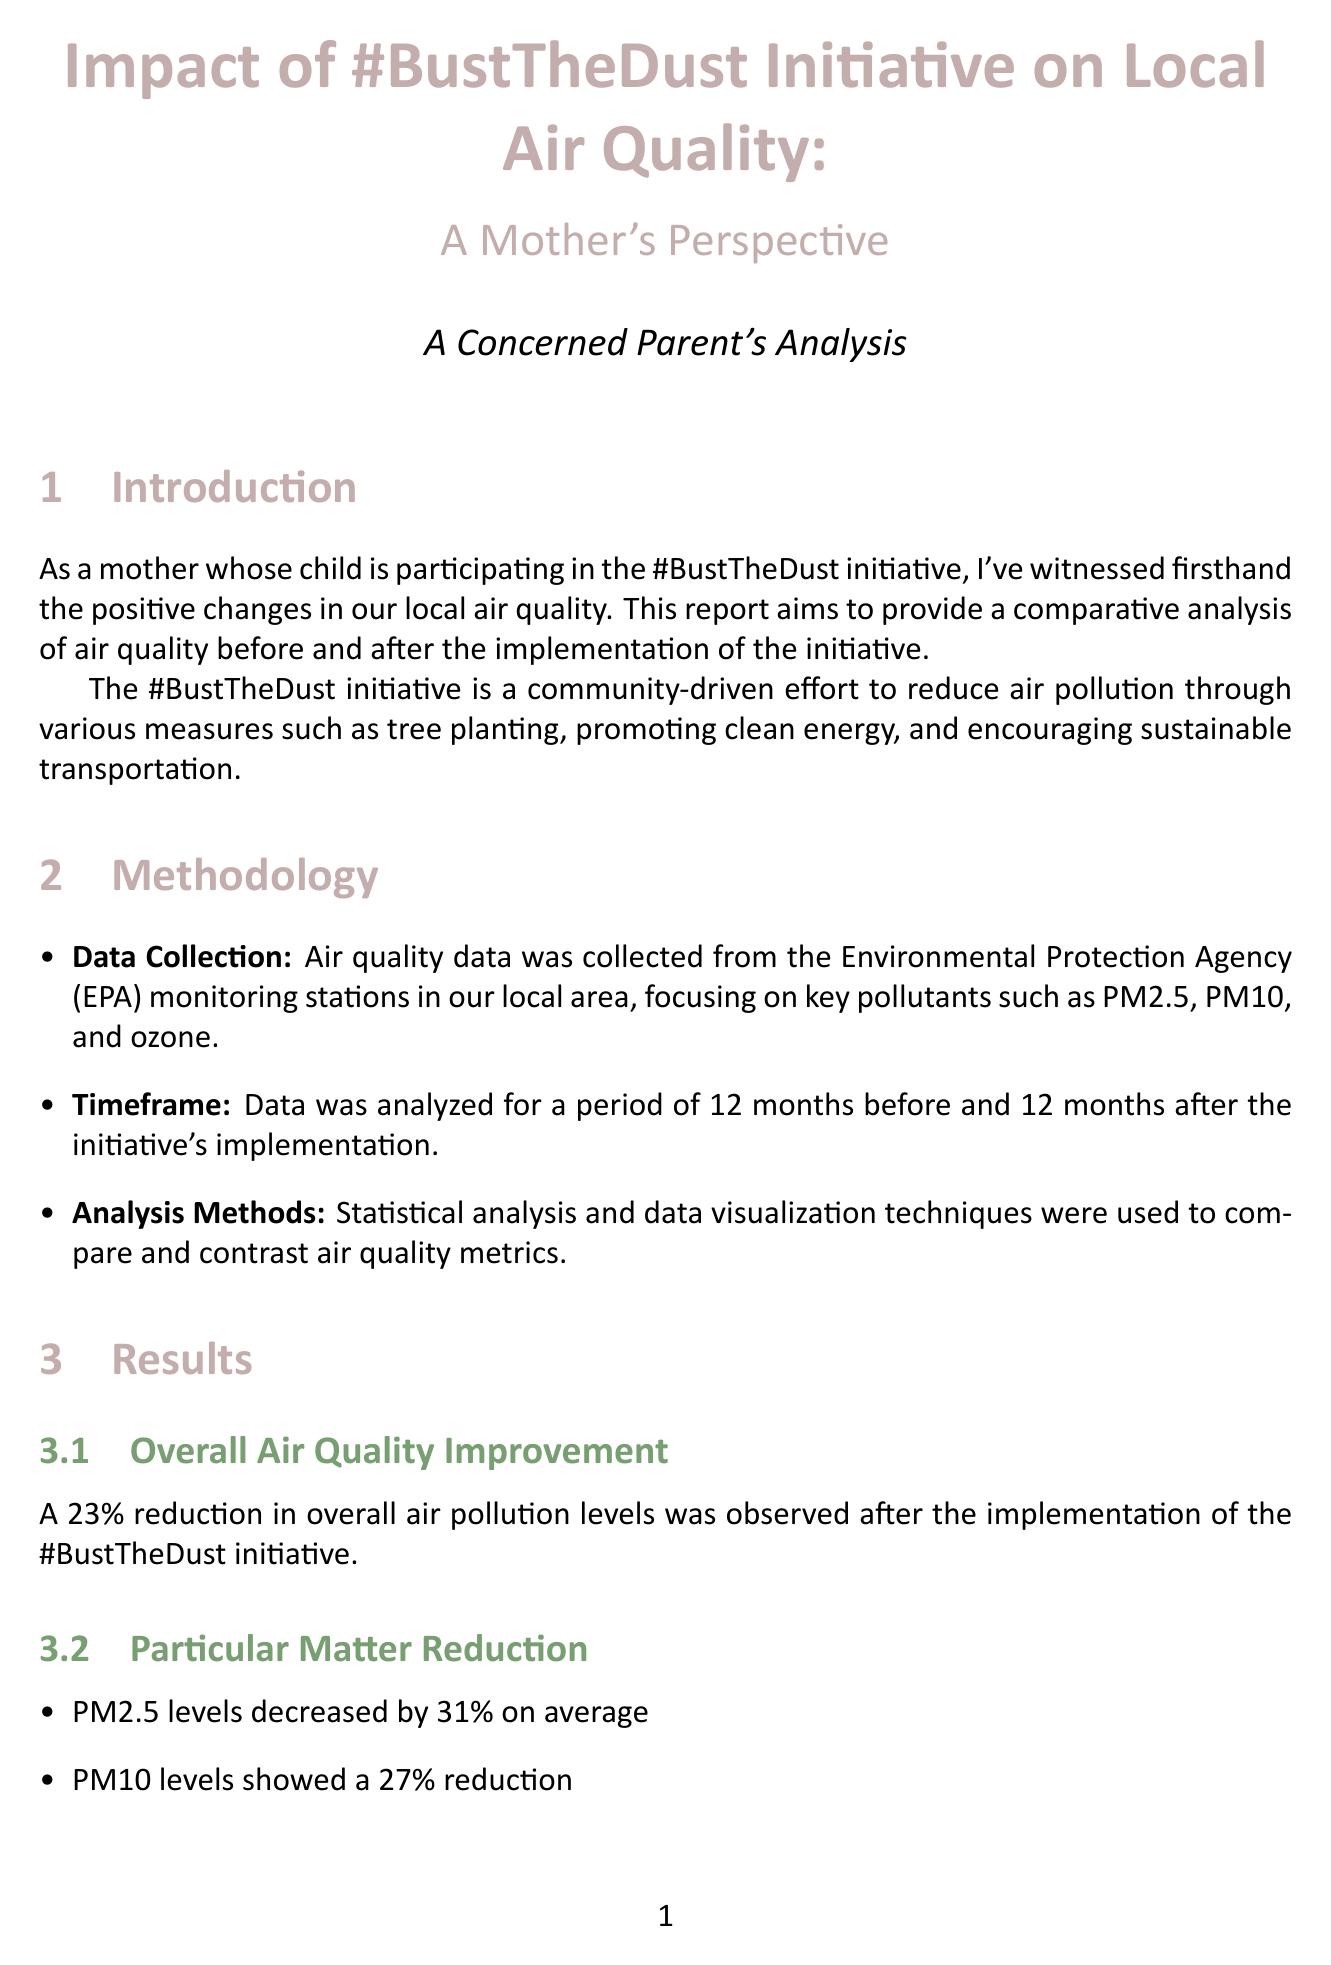What is the percentage reduction in PM2.5 levels? PM2.5 levels decreased by 31% on average, according to the results section of the report.
Answer: 31% What is the main goal of the #BustTheDust initiative? The initiative aims to reduce air pollution through various community-driven efforts, as described in the introduction.
Answer: Reduce air pollution How much did asthma-related emergency room visits decrease? Local pediatricians reported a 22% decrease in asthma-related emergency room visits among children aged 5-12, as mentioned in the health impact section.
Answer: 22% What was the increase in community event attendance compared to pre-initiative levels? Attendance at community clean-air events increased by 65% compared to pre-initiative levels, noted in the community feedback section.
Answer: 65% Which month showed the most significant reduction in smog-related pollutants? The report states that the most significant improvements were observed during summer months, as stated in the seasonal variations section.
Answer: Summer months What method was used to analyze air quality data? Statistical analysis and data visualization techniques were employed for comparing air quality metrics, as detailed in the methodology section.
Answer: Statistical analysis What percentage of parents expressed satisfaction with the initiative? According to the community feedback section, 92% of parents expressed satisfaction with the initiative's impact on local air quality.
Answer: 92% What is the overall percentage reduction in air pollution levels after the initiative? A 23% reduction in overall air pollution levels was observed after the initiative's implementation, as highlighted in the results section.
Answer: 23% What was the reported reduction in severe allergy cases? Allergy specialists noted a 15% reduction in severe allergy cases during peak pollen seasons, mentioned in the health impact section.
Answer: 15% 